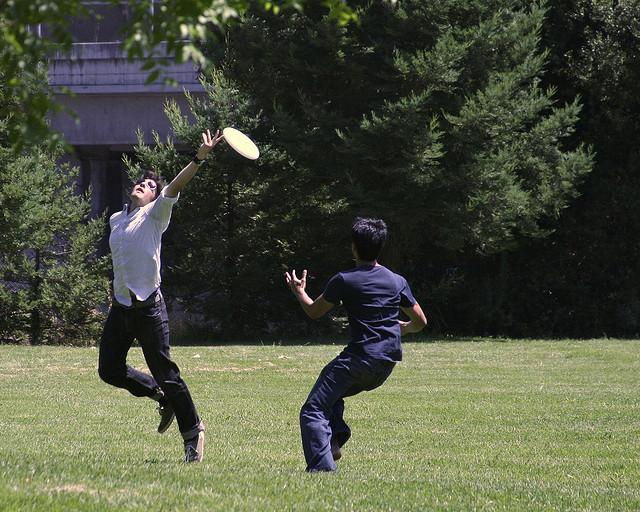Are the trees blooming?
Write a very short answer. No. How many people are there?
Keep it brief. 2. Are these people playing a game or are they dancing?
Keep it brief. Game. Sunny or overcast?
Give a very brief answer. Sunny. Did the man just throw, or is he about to catch?
Quick response, please. Catch. What are they playing with?
Keep it brief. Frisbee. 